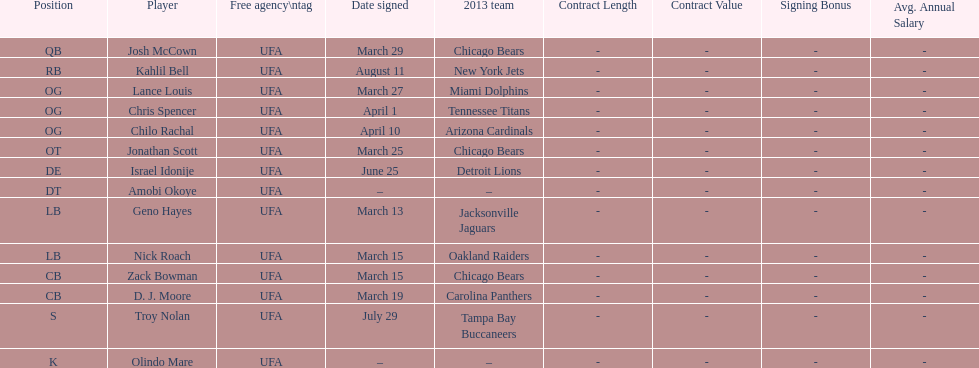Before troy nolan, who was the last player to be signed? Israel Idonije. 